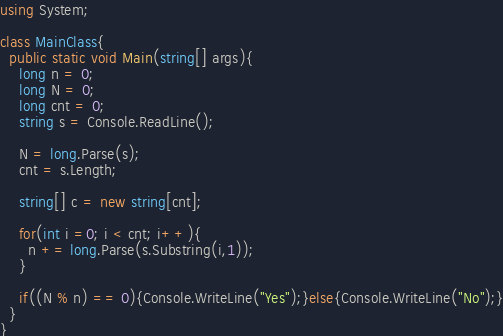Convert code to text. <code><loc_0><loc_0><loc_500><loc_500><_C#_>using System;
 
class MainClass{
  public static void Main(string[] args){
    long n = 0;
    long N = 0;
    long cnt = 0;
    string s = Console.ReadLine();
 
    N = long.Parse(s);
    cnt = s.Length;
 
    string[] c = new string[cnt];
 
    for(int i =0; i < cnt; i++){
      n += long.Parse(s.Substring(i,1));
    }
 
    if((N % n) == 0){Console.WriteLine("Yes");}else{Console.WriteLine("No");}
  }
}</code> 